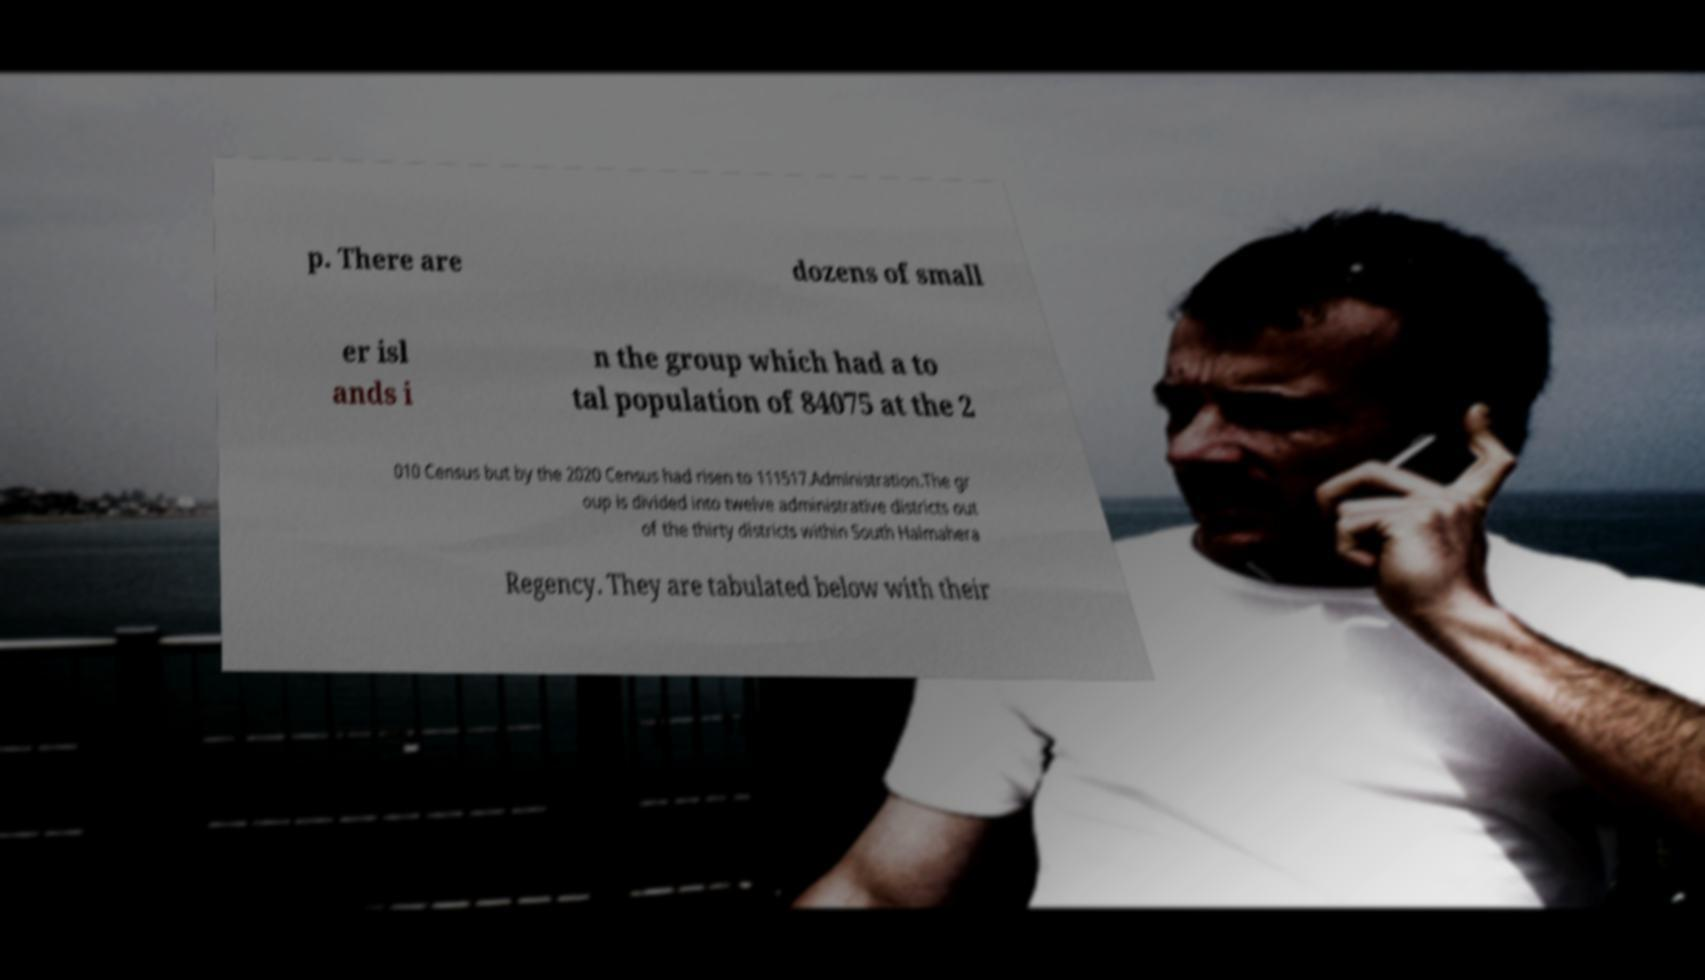Please read and relay the text visible in this image. What does it say? p. There are dozens of small er isl ands i n the group which had a to tal population of 84075 at the 2 010 Census but by the 2020 Census had risen to 111517.Administration.The gr oup is divided into twelve administrative districts out of the thirty districts within South Halmahera Regency. They are tabulated below with their 